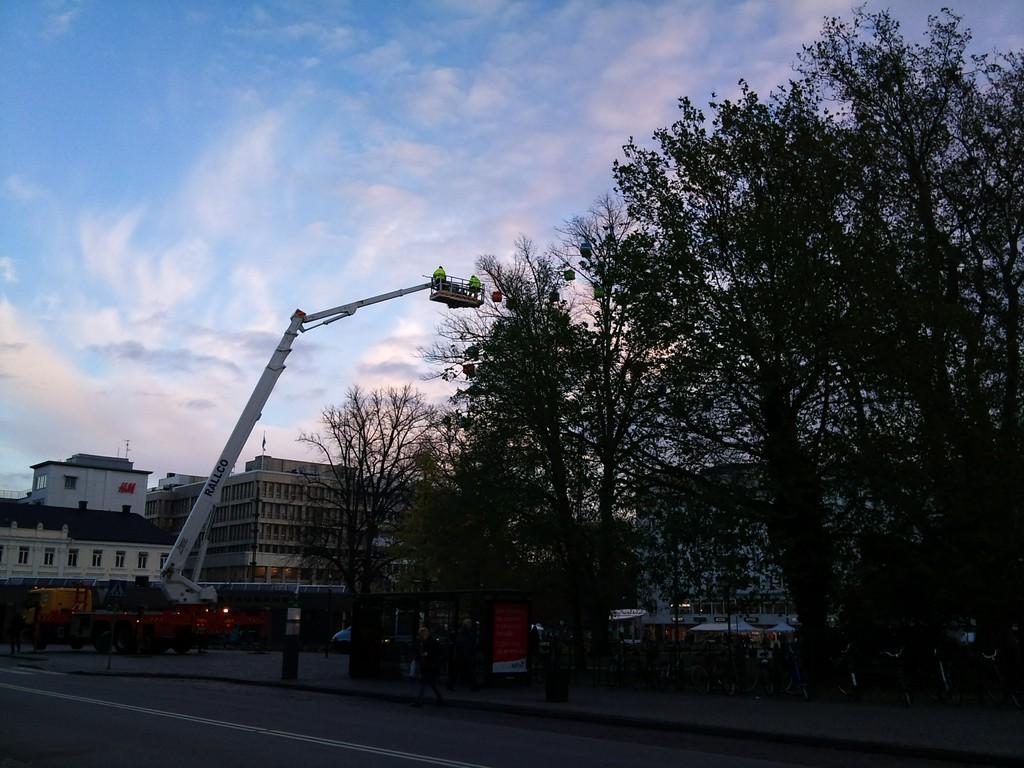Could you give a brief overview of what you see in this image? In this image I can see the road. To the side of the road I can see many boards, crane, vehicles and the tree. In the background I can see the buildings, clouds and the sky. 